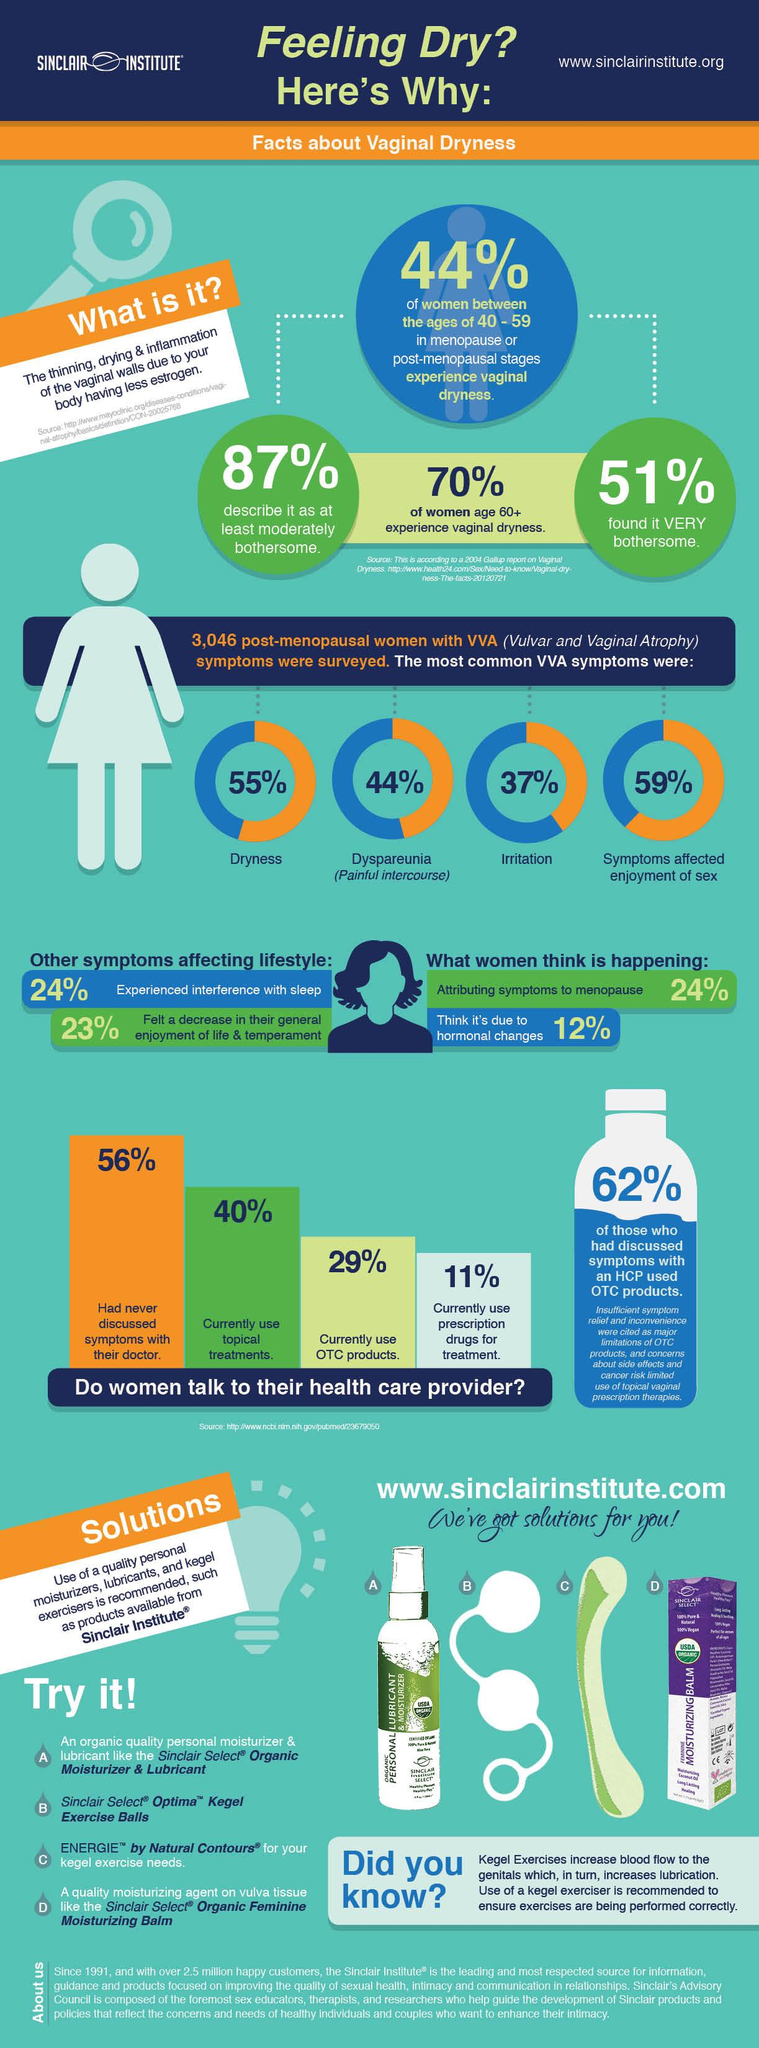Point out several critical features in this image. The Sinclair Institute offers a fourth product called Moisturizing Balm. According to the given information, a significant percentage of women aged 60 and above, 87%, 70%, or 51%, experienced vaginal dryness. Specifically, 70% of the women in this age group reported experiencing vaginal dryness. According to the survey, 55%, 44%, 37%, and 59% of women reported experiencing irritation as a symptom of vulvar and vaginal atrophy. Sinclair Select Optima and ENERGIE pelvic floor muscle strengthening products are designed to support the development and improvement of pelvic floor muscles. 